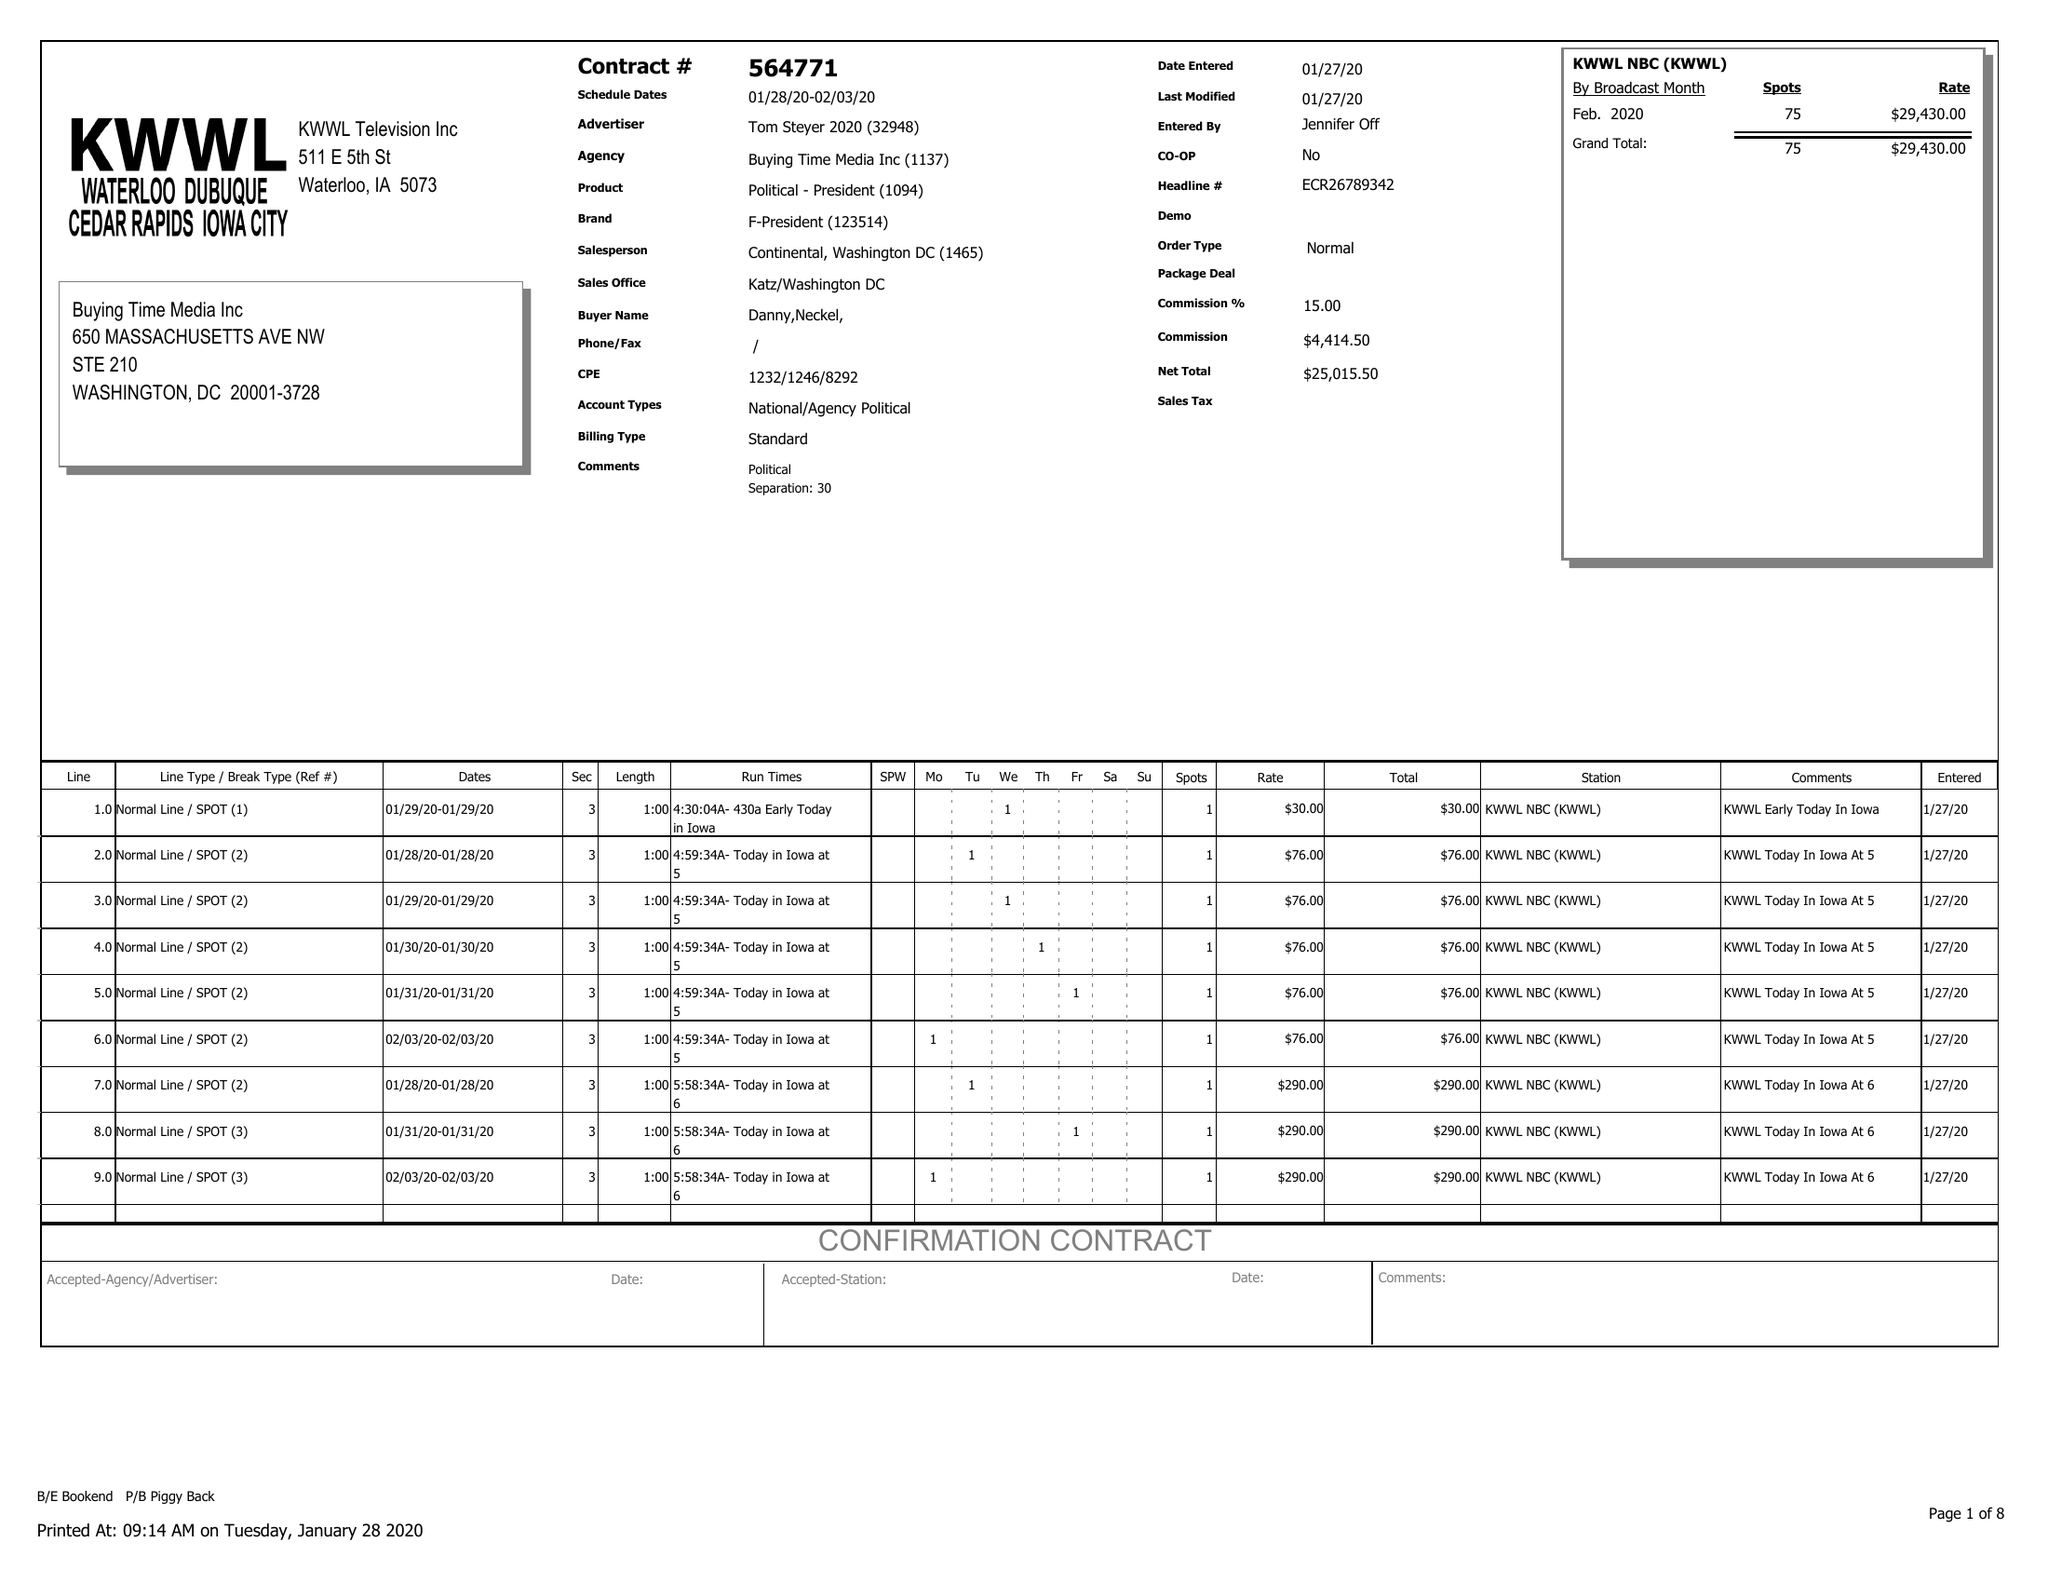What is the value for the advertiser?
Answer the question using a single word or phrase. TOM STEYER 2020 